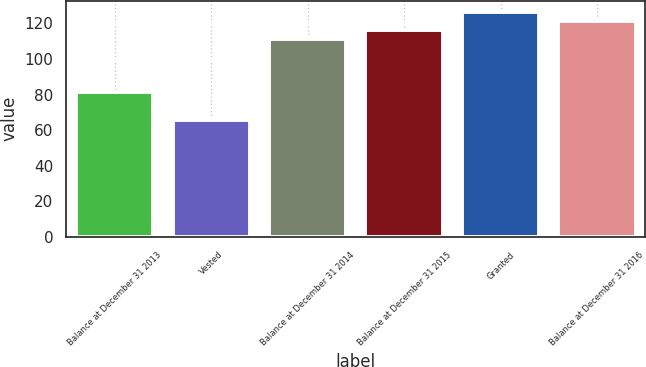<chart> <loc_0><loc_0><loc_500><loc_500><bar_chart><fcel>Balance at December 31 2013<fcel>Vested<fcel>Balance at December 31 2014<fcel>Balance at December 31 2015<fcel>Granted<fcel>Balance at December 31 2016<nl><fcel>81.49<fcel>65.88<fcel>110.94<fcel>116.12<fcel>126.48<fcel>121.3<nl></chart> 